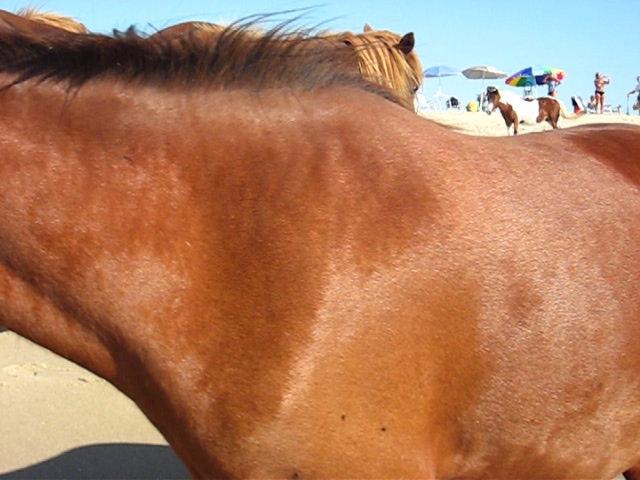How many animals in the picture?
Keep it brief. 2. Is this a zoo?
Give a very brief answer. No. How many umbrella's are visible?
Be succinct. 3. 